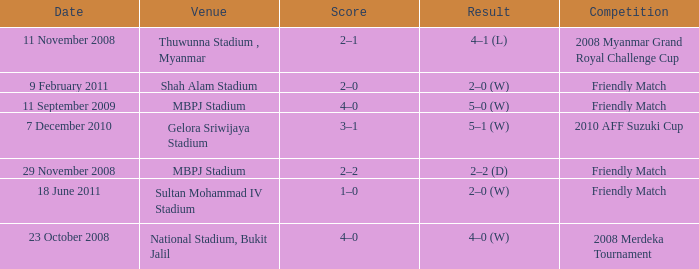Would you be able to parse every entry in this table? {'header': ['Date', 'Venue', 'Score', 'Result', 'Competition'], 'rows': [['11 November 2008', 'Thuwunna Stadium , Myanmar', '2–1', '4–1 (L)', '2008 Myanmar Grand Royal Challenge Cup'], ['9 February 2011', 'Shah Alam Stadium', '2–0', '2–0 (W)', 'Friendly Match'], ['11 September 2009', 'MBPJ Stadium', '4–0', '5–0 (W)', 'Friendly Match'], ['7 December 2010', 'Gelora Sriwijaya Stadium', '3–1', '5–1 (W)', '2010 AFF Suzuki Cup'], ['29 November 2008', 'MBPJ Stadium', '2–2', '2–2 (D)', 'Friendly Match'], ['18 June 2011', 'Sultan Mohammad IV Stadium', '1–0', '2–0 (W)', 'Friendly Match'], ['23 October 2008', 'National Stadium, Bukit Jalil', '4–0', '4–0 (W)', '2008 Merdeka Tournament']]} What was the Score in Gelora Sriwijaya Stadium? 3–1. 